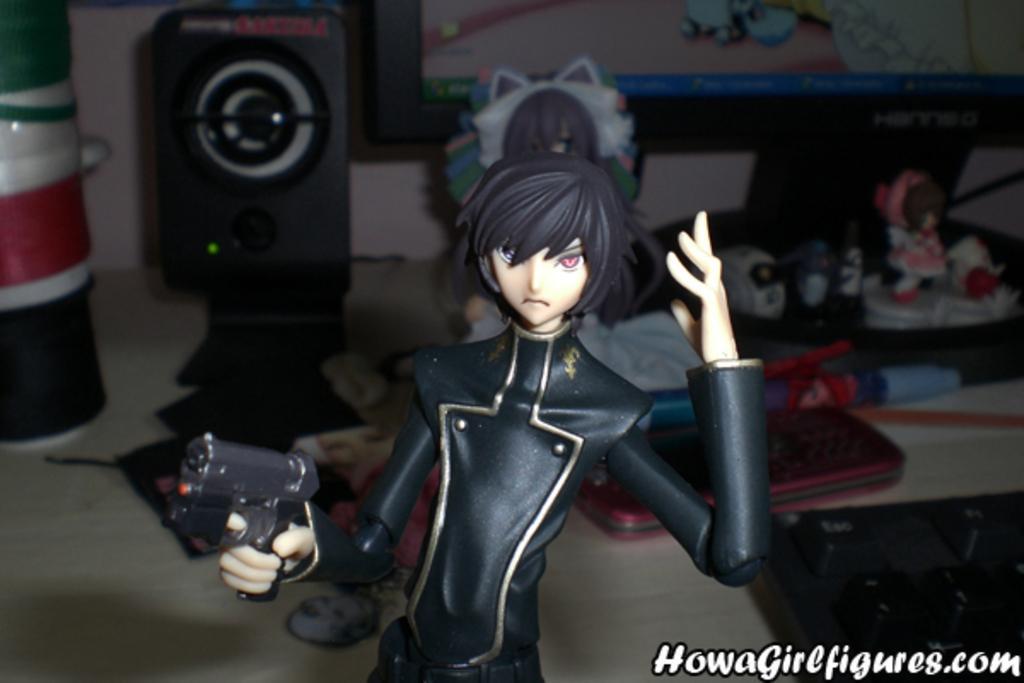In one or two sentences, can you explain what this image depicts? A person is holding gun in the hand, here there are buckets and a speaker, here there are toys, this is monitor. 